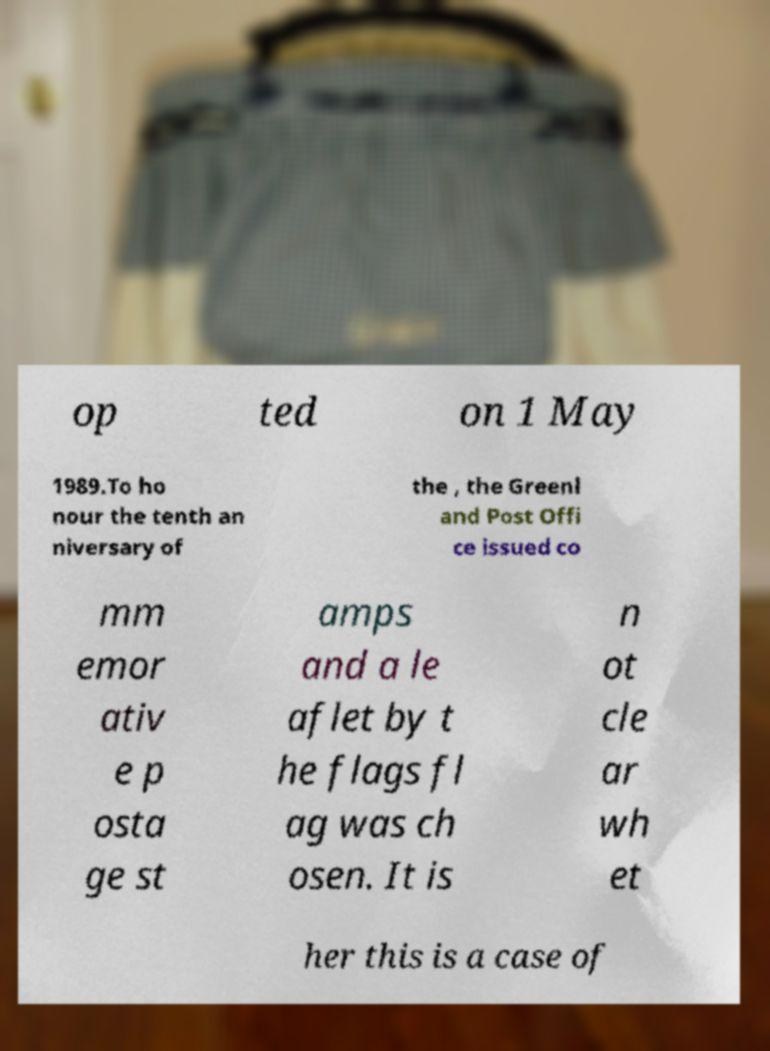Can you accurately transcribe the text from the provided image for me? op ted on 1 May 1989.To ho nour the tenth an niversary of the , the Greenl and Post Offi ce issued co mm emor ativ e p osta ge st amps and a le aflet by t he flags fl ag was ch osen. It is n ot cle ar wh et her this is a case of 